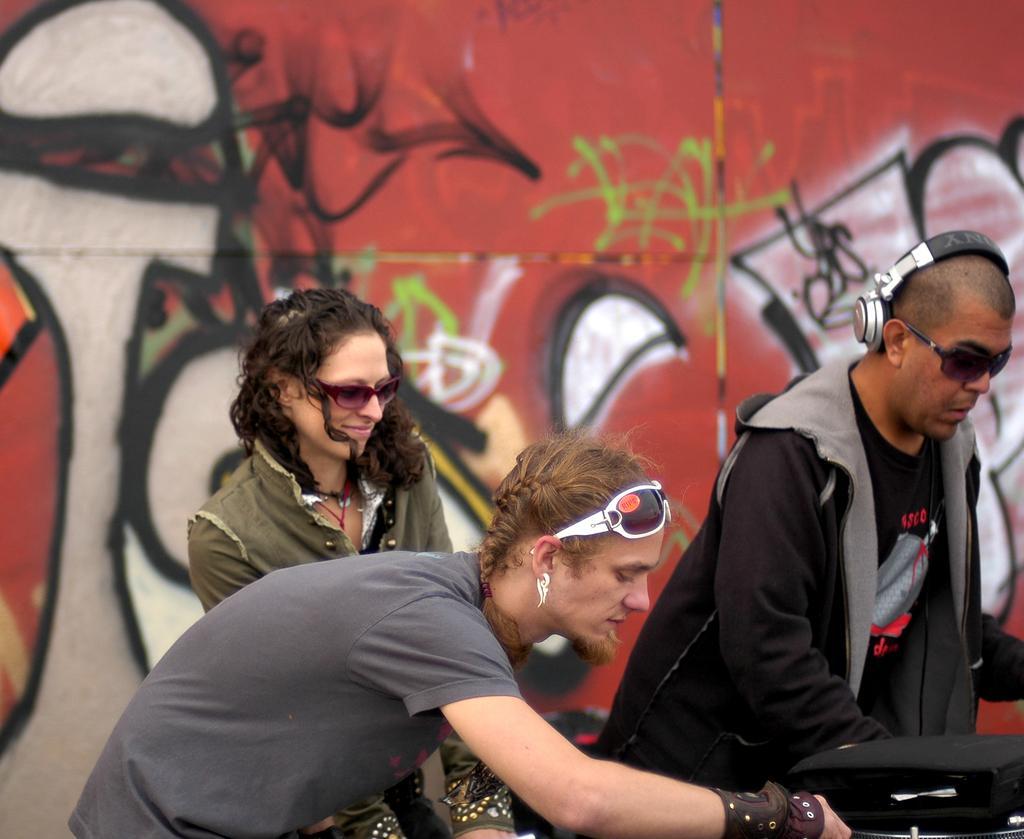Describe this image in one or two sentences. As we can see in the image in the front there are few people here and there and in the background there is a building. 